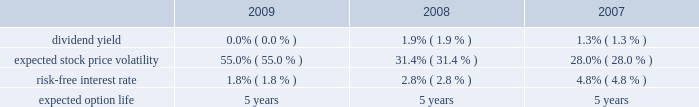Royal caribbean cruises ltd .
Notes to the consolidated financial statements 2014 ( continued ) note 9 .
Stock-based employee compensation we have four stock-based compensation plans , which provide for awards to our officers , directors and key employees .
The plans consist of a 1990 employee stock option plan , a 1995 incentive stock option plan , a 2000 stock award plan , and a 2008 equity plan .
The 1990 stock option plan and the 1995 incentive stock option plan terminated by their terms in march 2000 and february 2005 , respectively .
The 2000 stock award plan , as amended , and the 2008 equity plan provide for the issuance of ( i ) incentive and non-qualified stock options , ( ii ) stock appreciation rights , ( iii ) restricted stock , ( iv ) restricted stock units and ( v ) up to 13000000 performance shares of our common stock for the 2000 stock award plan and up to 5000000 performance shares of our common stock for the 2008 equity plan .
During any calendar year , no one individual shall be granted awards of more than 500000 shares .
Options and restricted stock units outstanding as of december 31 , 2009 vest in equal installments over four to five years from the date of grant .
Generally , options and restricted stock units are forfeited if the recipient ceases to be a director or employee before the shares vest .
Options are granted at a price not less than the fair value of the shares on the date of grant and expire not later than ten years after the date of grant .
We also provide an employee stock purchase plan to facilitate the purchase by employees of up to 800000 shares of common stock in the aggregate .
Offerings to employees are made on a quarterly basis .
Subject to certain limitations , the purchase price for each share of common stock is equal to 90% ( 90 % ) of the average of the market prices of the common stock as reported on the new york stock exchange on the first business day of the purchase period and the last business day of each month of the purchase period .
Shares of common stock of 65005 , 36836 and 20759 were issued under the espp at a weighted-average price of $ 12.78 , $ 20.97 and $ 37.25 during 2009 , 2008 and 2007 , respectively .
Under the chief executive officer 2019s employment agreement we contributed 10086 shares of our common stock quarterly , to a maximum of 806880 shares , to a trust on his behalf .
In january 2009 , the employment agreement and related trust agreement were amended .
Consequently , 768018 shares were distributed from the trust and future quarterly share distributions are issued directly to the chief executive officer .
Total compensation expenses recognized for employee stock-based compensation for the year ended december 31 , 2009 was $ 16.8 million .
Of this amount , $ 16.2 million was included within marketing , selling and administrative expenses and $ 0.6 million was included within payroll and related expenses .
Total compensation expense recognized for employee stock-based compensation for the year ended december 31 , 2008 was $ 5.7 million .
Of this amount , $ 6.4 million , which included a benefit of approximately $ 8.2 million due to a change in the employee forfeiture rate assumption was included within marketing , selling and administrative expenses and income of $ 0.7 million was included within payroll and related expenses which also included a benefit of approximately $ 1.0 million due to the change in the forfeiture rate .
Total compensation expenses recognized for employee stock-based compensation for the year ended december 31 , 2007 was $ 19.0 million .
Of this amount , $ 16.3 million was included within marketing , selling and administrative expenses and $ 2.7 million was included within payroll and related expenses .
The fair value of each stock option grant is estimated on the date of grant using the black-scholes option pricing model .
The estimated fair value of stock options , less estimated forfeitures , is amortized over the vesting period using the graded-vesting method .
The assumptions used in the black-scholes option-pricing model are as follows : expected volatility was based on a combination of historical and implied volatilities .
The risk-free interest rate is based on united states treasury zero coupon issues with a remaining term equal to the expected option life assumed at the date of grant .
The expected term was calculated based on historical experience and represents the time period options actually remain outstanding .
We estimate forfeitures based on historical pre-vesting forfeiture rates and revise those estimates as appropriate to reflect actual experience .
In 2008 , we increased our estimated forfeiture rate from 4% ( 4 % ) for options and 8.5% ( 8.5 % ) for restricted stock units to 20% ( 20 % ) to reflect changes in employee retention rates. .

What was the percentage increase in the shares of common stock of? 
Computations: ((65005 - 36836) / 36836)
Answer: 0.76471. 